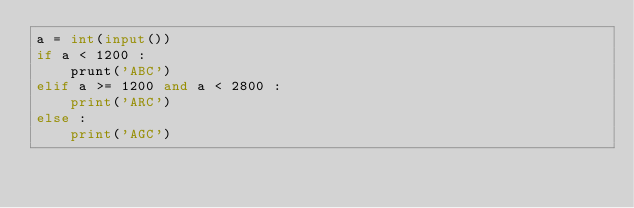<code> <loc_0><loc_0><loc_500><loc_500><_Python_>a = int(input())
if a < 1200 :
    prunt('ABC')
elif a >= 1200 and a < 2800 :
    print('ARC')
else :
    print('AGC')</code> 